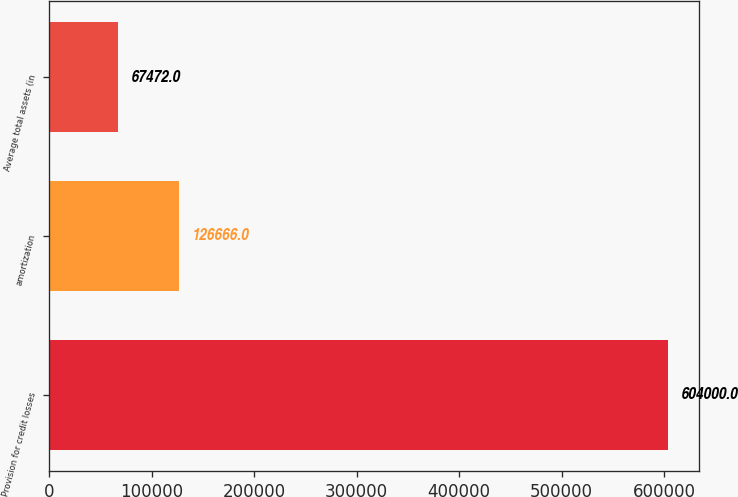Convert chart to OTSL. <chart><loc_0><loc_0><loc_500><loc_500><bar_chart><fcel>Provision for credit losses<fcel>amortization<fcel>Average total assets (in<nl><fcel>604000<fcel>126666<fcel>67472<nl></chart> 